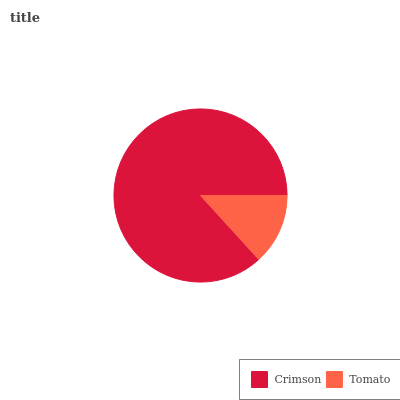Is Tomato the minimum?
Answer yes or no. Yes. Is Crimson the maximum?
Answer yes or no. Yes. Is Tomato the maximum?
Answer yes or no. No. Is Crimson greater than Tomato?
Answer yes or no. Yes. Is Tomato less than Crimson?
Answer yes or no. Yes. Is Tomato greater than Crimson?
Answer yes or no. No. Is Crimson less than Tomato?
Answer yes or no. No. Is Crimson the high median?
Answer yes or no. Yes. Is Tomato the low median?
Answer yes or no. Yes. Is Tomato the high median?
Answer yes or no. No. Is Crimson the low median?
Answer yes or no. No. 